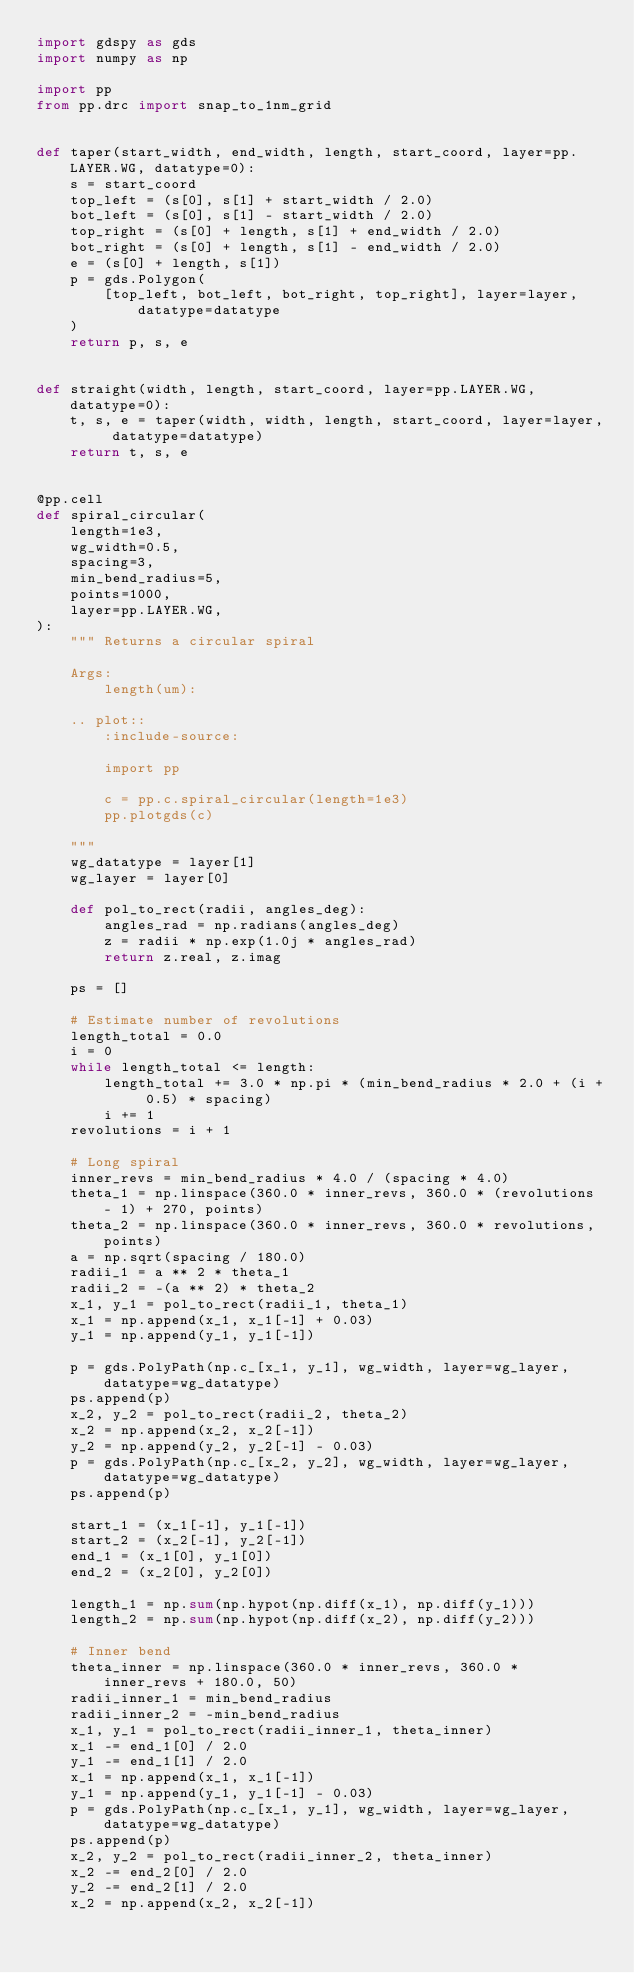<code> <loc_0><loc_0><loc_500><loc_500><_Python_>import gdspy as gds
import numpy as np

import pp
from pp.drc import snap_to_1nm_grid


def taper(start_width, end_width, length, start_coord, layer=pp.LAYER.WG, datatype=0):
    s = start_coord
    top_left = (s[0], s[1] + start_width / 2.0)
    bot_left = (s[0], s[1] - start_width / 2.0)
    top_right = (s[0] + length, s[1] + end_width / 2.0)
    bot_right = (s[0] + length, s[1] - end_width / 2.0)
    e = (s[0] + length, s[1])
    p = gds.Polygon(
        [top_left, bot_left, bot_right, top_right], layer=layer, datatype=datatype
    )
    return p, s, e


def straight(width, length, start_coord, layer=pp.LAYER.WG, datatype=0):
    t, s, e = taper(width, width, length, start_coord, layer=layer, datatype=datatype)
    return t, s, e


@pp.cell
def spiral_circular(
    length=1e3,
    wg_width=0.5,
    spacing=3,
    min_bend_radius=5,
    points=1000,
    layer=pp.LAYER.WG,
):
    """ Returns a circular spiral

    Args:
        length(um):

    .. plot::
        :include-source:

        import pp

        c = pp.c.spiral_circular(length=1e3)
        pp.plotgds(c)

    """
    wg_datatype = layer[1]
    wg_layer = layer[0]

    def pol_to_rect(radii, angles_deg):
        angles_rad = np.radians(angles_deg)
        z = radii * np.exp(1.0j * angles_rad)
        return z.real, z.imag

    ps = []

    # Estimate number of revolutions
    length_total = 0.0
    i = 0
    while length_total <= length:
        length_total += 3.0 * np.pi * (min_bend_radius * 2.0 + (i + 0.5) * spacing)
        i += 1
    revolutions = i + 1

    # Long spiral
    inner_revs = min_bend_radius * 4.0 / (spacing * 4.0)
    theta_1 = np.linspace(360.0 * inner_revs, 360.0 * (revolutions - 1) + 270, points)
    theta_2 = np.linspace(360.0 * inner_revs, 360.0 * revolutions, points)
    a = np.sqrt(spacing / 180.0)
    radii_1 = a ** 2 * theta_1
    radii_2 = -(a ** 2) * theta_2
    x_1, y_1 = pol_to_rect(radii_1, theta_1)
    x_1 = np.append(x_1, x_1[-1] + 0.03)
    y_1 = np.append(y_1, y_1[-1])

    p = gds.PolyPath(np.c_[x_1, y_1], wg_width, layer=wg_layer, datatype=wg_datatype)
    ps.append(p)
    x_2, y_2 = pol_to_rect(radii_2, theta_2)
    x_2 = np.append(x_2, x_2[-1])
    y_2 = np.append(y_2, y_2[-1] - 0.03)
    p = gds.PolyPath(np.c_[x_2, y_2], wg_width, layer=wg_layer, datatype=wg_datatype)
    ps.append(p)

    start_1 = (x_1[-1], y_1[-1])
    start_2 = (x_2[-1], y_2[-1])
    end_1 = (x_1[0], y_1[0])
    end_2 = (x_2[0], y_2[0])

    length_1 = np.sum(np.hypot(np.diff(x_1), np.diff(y_1)))
    length_2 = np.sum(np.hypot(np.diff(x_2), np.diff(y_2)))

    # Inner bend
    theta_inner = np.linspace(360.0 * inner_revs, 360.0 * inner_revs + 180.0, 50)
    radii_inner_1 = min_bend_radius
    radii_inner_2 = -min_bend_radius
    x_1, y_1 = pol_to_rect(radii_inner_1, theta_inner)
    x_1 -= end_1[0] / 2.0
    y_1 -= end_1[1] / 2.0
    x_1 = np.append(x_1, x_1[-1])
    y_1 = np.append(y_1, y_1[-1] - 0.03)
    p = gds.PolyPath(np.c_[x_1, y_1], wg_width, layer=wg_layer, datatype=wg_datatype)
    ps.append(p)
    x_2, y_2 = pol_to_rect(radii_inner_2, theta_inner)
    x_2 -= end_2[0] / 2.0
    y_2 -= end_2[1] / 2.0
    x_2 = np.append(x_2, x_2[-1])</code> 